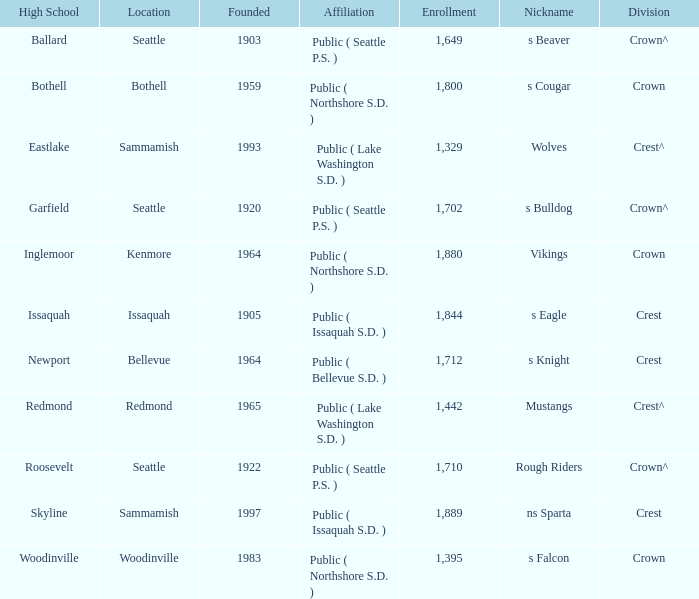What is the relationship of a site called issaquah? Public ( Issaquah S.D. ). 